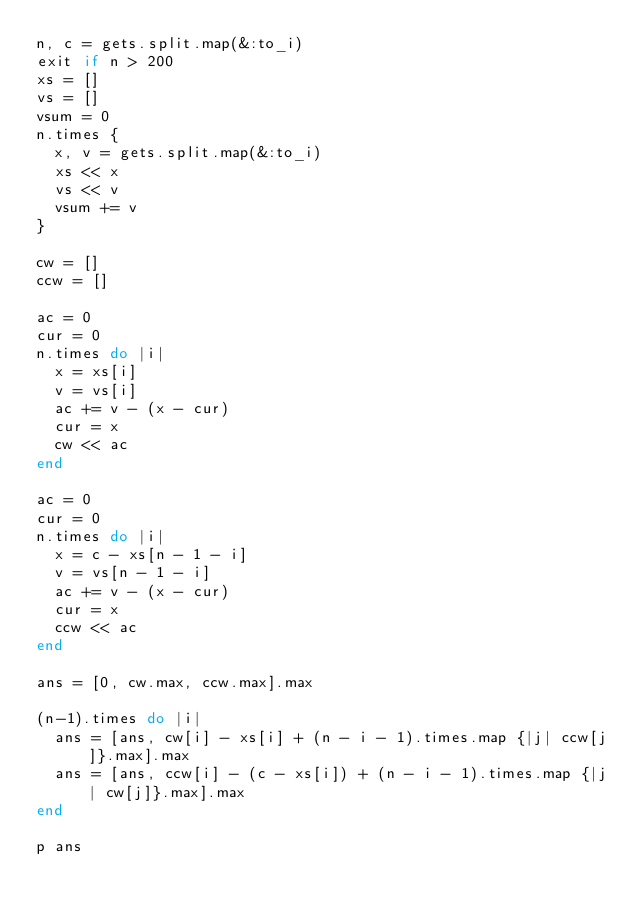Convert code to text. <code><loc_0><loc_0><loc_500><loc_500><_Ruby_>n, c = gets.split.map(&:to_i)
exit if n > 200
xs = []
vs = []
vsum = 0
n.times {
  x, v = gets.split.map(&:to_i)
  xs << x
  vs << v
  vsum += v
}

cw = []
ccw = []

ac = 0
cur = 0
n.times do |i|
  x = xs[i]
  v = vs[i]
  ac += v - (x - cur)
  cur = x
  cw << ac
end

ac = 0
cur = 0
n.times do |i|
  x = c - xs[n - 1 - i]
  v = vs[n - 1 - i]
  ac += v - (x - cur)
  cur = x
  ccw << ac
end

ans = [0, cw.max, ccw.max].max

(n-1).times do |i|
  ans = [ans, cw[i] - xs[i] + (n - i - 1).times.map {|j| ccw[j]}.max].max
  ans = [ans, ccw[i] - (c - xs[i]) + (n - i - 1).times.map {|j| cw[j]}.max].max
end

p ans
</code> 